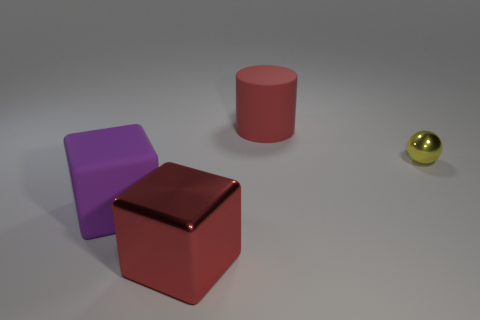What shape is the matte thing that is the same color as the large metal object?
Offer a very short reply. Cylinder. Are there any shiny balls that have the same size as the purple block?
Your answer should be compact. No. There is a large block right of the big rubber object that is on the left side of the large red thing that is behind the tiny yellow object; what is its color?
Make the answer very short. Red. Is the material of the large red cylinder the same as the cube behind the big red metallic object?
Your answer should be compact. Yes. The purple matte object that is the same shape as the big metallic thing is what size?
Your answer should be very brief. Large. Are there the same number of large red objects that are in front of the large red metallic thing and shiny blocks that are behind the large rubber cylinder?
Make the answer very short. Yes. How many other things are there of the same material as the large red cylinder?
Provide a short and direct response. 1. Are there the same number of big purple matte objects that are behind the tiny thing and yellow cylinders?
Provide a short and direct response. Yes. Does the red matte object have the same size as the thing that is left of the red metal thing?
Ensure brevity in your answer.  Yes. There is a large rubber object to the right of the purple rubber cube; what is its shape?
Offer a very short reply. Cylinder. 